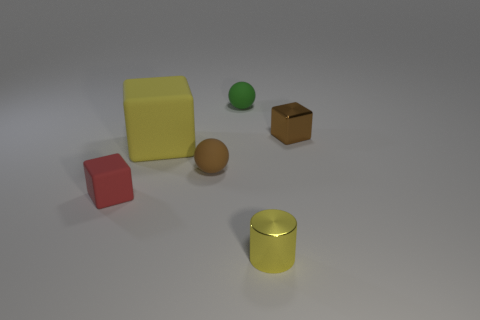Subtract all yellow matte cubes. How many cubes are left? 2 Add 3 brown metallic cubes. How many objects exist? 9 Subtract all brown blocks. How many blocks are left? 2 Subtract 1 blocks. How many blocks are left? 2 Add 3 large blue matte objects. How many large blue matte objects exist? 3 Subtract 0 purple cylinders. How many objects are left? 6 Subtract all balls. How many objects are left? 4 Subtract all gray spheres. Subtract all yellow cylinders. How many spheres are left? 2 Subtract all small balls. Subtract all brown metal cubes. How many objects are left? 3 Add 6 small brown balls. How many small brown balls are left? 7 